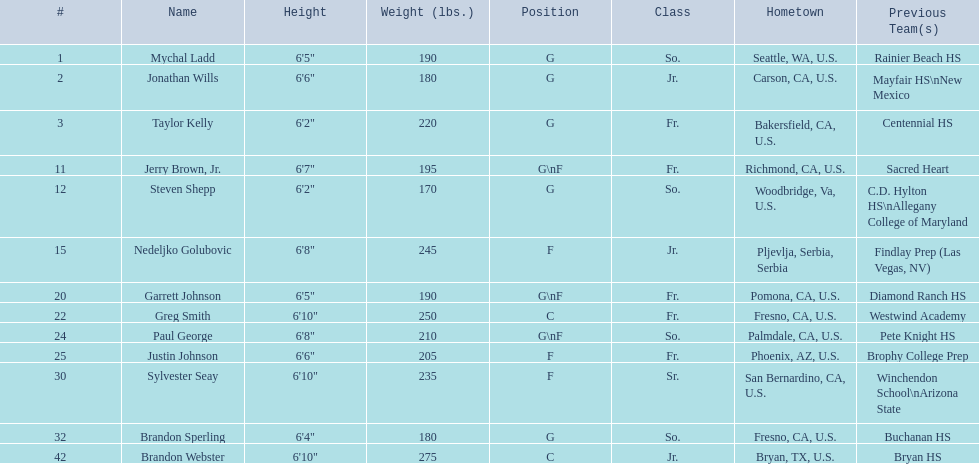Who are the athletes in the 2009-10 fresno state bulldogs men's basketball team? Mychal Ladd, Jonathan Wills, Taylor Kelly, Jerry Brown, Jr., Steven Shepp, Nedeljko Golubovic, Garrett Johnson, Greg Smith, Paul George, Justin Johnson, Sylvester Seay, Brandon Sperling, Brandon Webster. What are their heights? 6'5", 6'6", 6'2", 6'7", 6'2", 6'8", 6'5", 6'10", 6'8", 6'6", 6'10", 6'4", 6'10". What is the minimum height? 6'2", 6'2". What is the lightest weight? 6'2". Who is that player? Steven Shepp. 